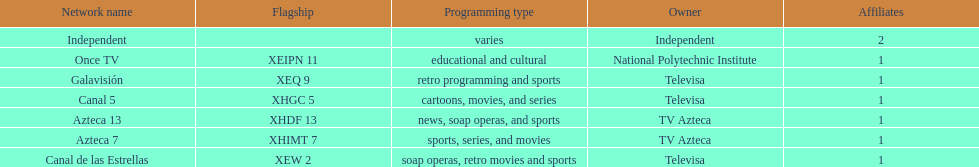What quantity of networks do not show sports events? 2. 